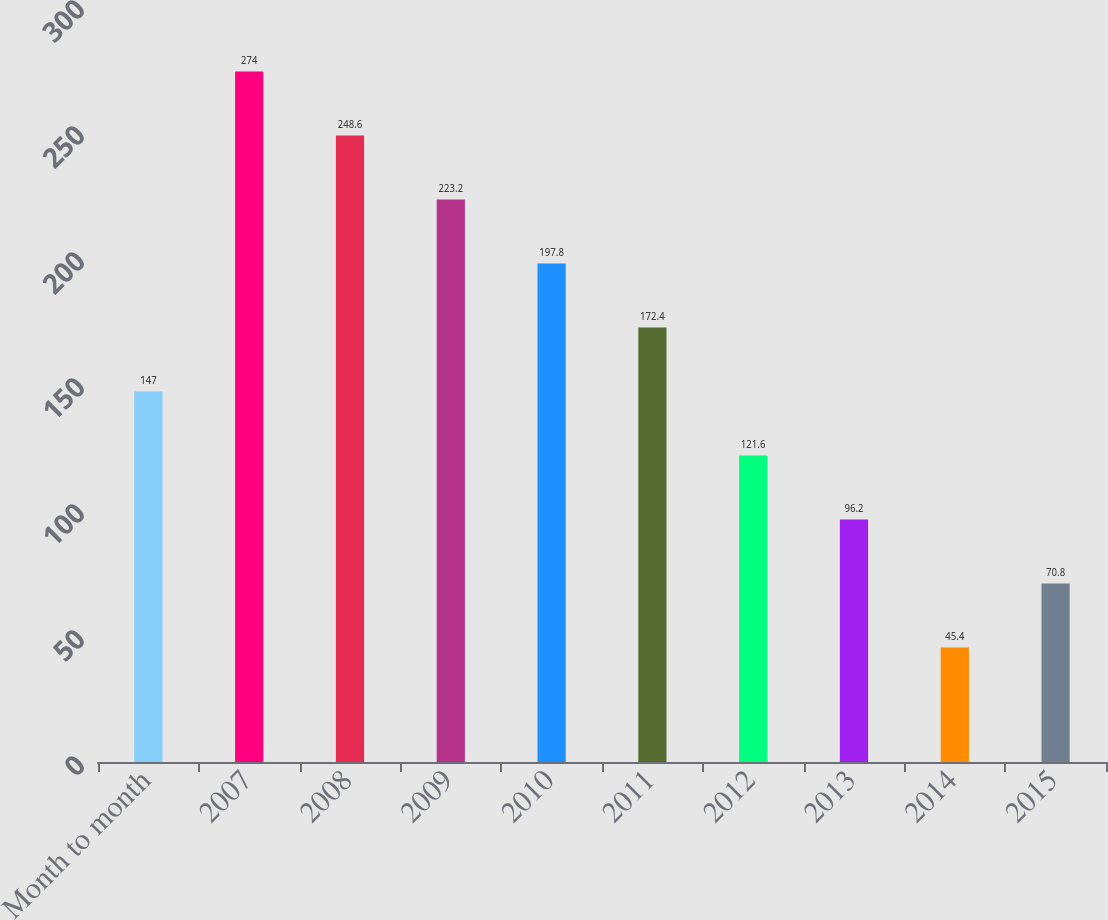Convert chart. <chart><loc_0><loc_0><loc_500><loc_500><bar_chart><fcel>Month to month<fcel>2007<fcel>2008<fcel>2009<fcel>2010<fcel>2011<fcel>2012<fcel>2013<fcel>2014<fcel>2015<nl><fcel>147<fcel>274<fcel>248.6<fcel>223.2<fcel>197.8<fcel>172.4<fcel>121.6<fcel>96.2<fcel>45.4<fcel>70.8<nl></chart> 